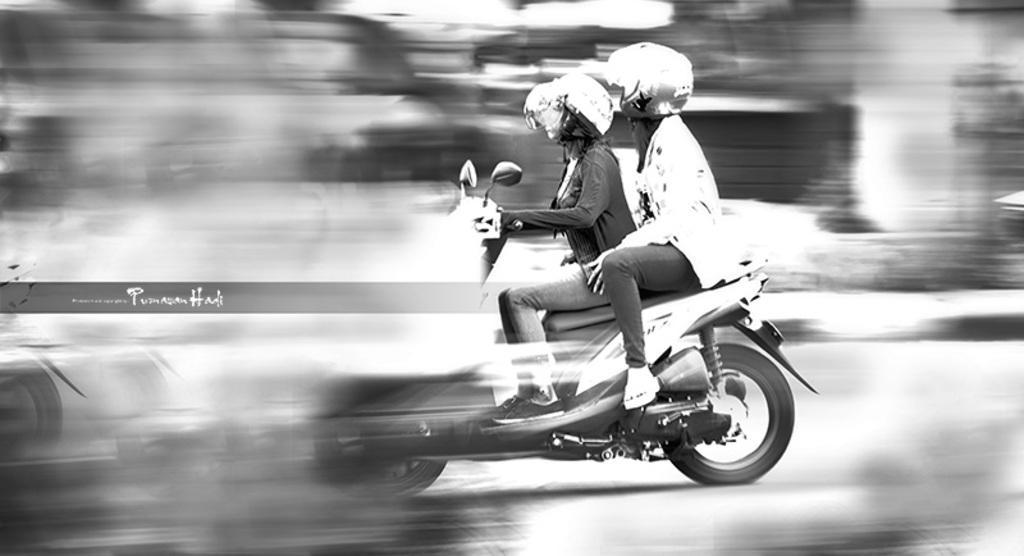Could you give a brief overview of what you see in this image? Two women are riding a bike on a road wearing helmets. 